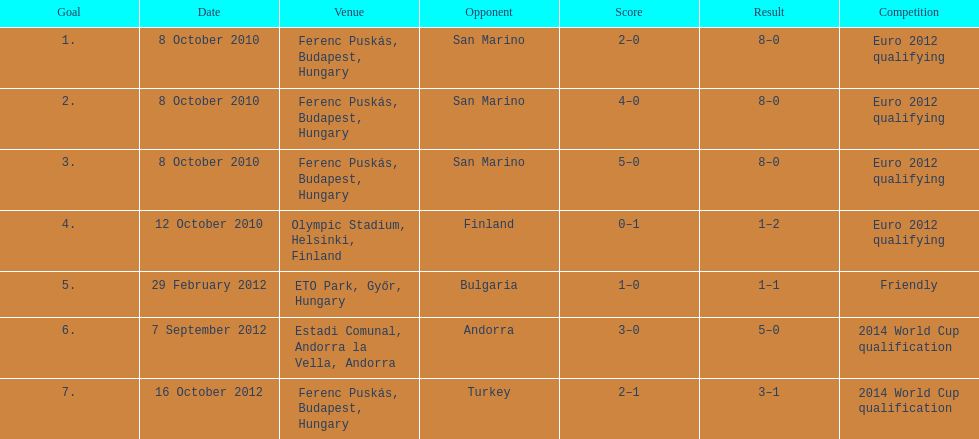What is the cumulative sum of international goals made by ádám szalai? 7. 